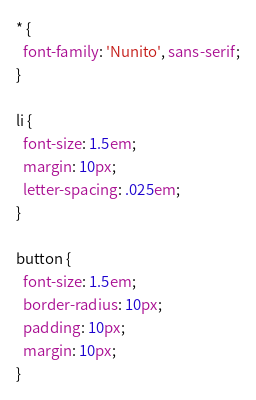<code> <loc_0><loc_0><loc_500><loc_500><_CSS_>* {
  font-family: 'Nunito', sans-serif;
}

li {
  font-size: 1.5em;
  margin: 10px;
  letter-spacing: .025em;
}

button {
  font-size: 1.5em;
  border-radius: 10px;
  padding: 10px;
  margin: 10px;
}
</code> 